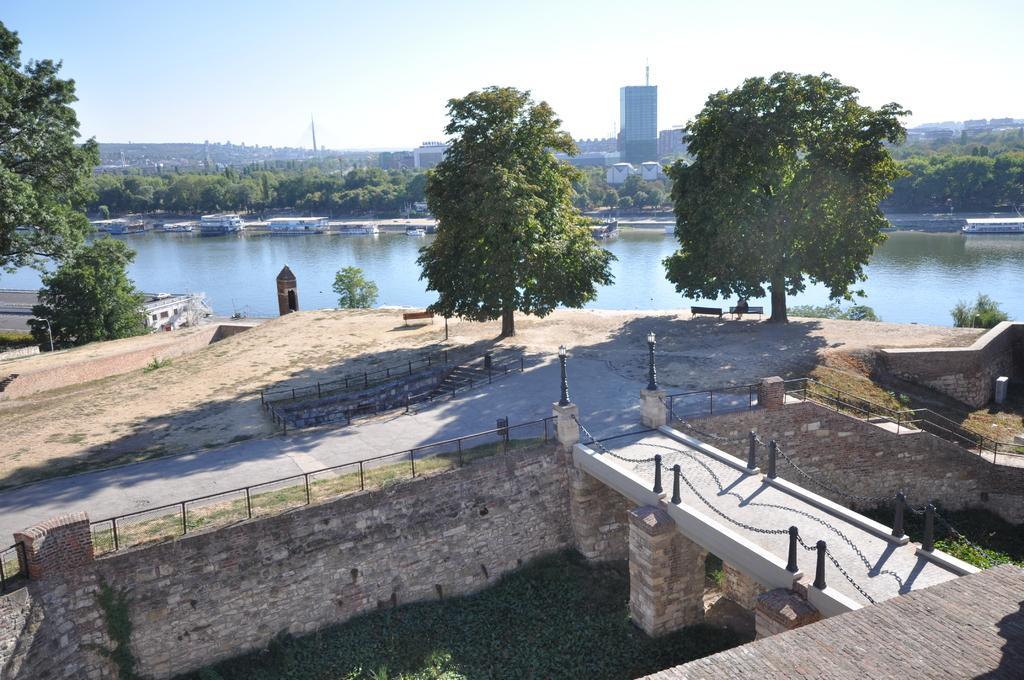Could you give a brief overview of what you see in this image? In the center of the image there is a lake and we can see boats on the lake. There are trees. At the bottom we can see a bridge. In the background there are buildings and sky. 